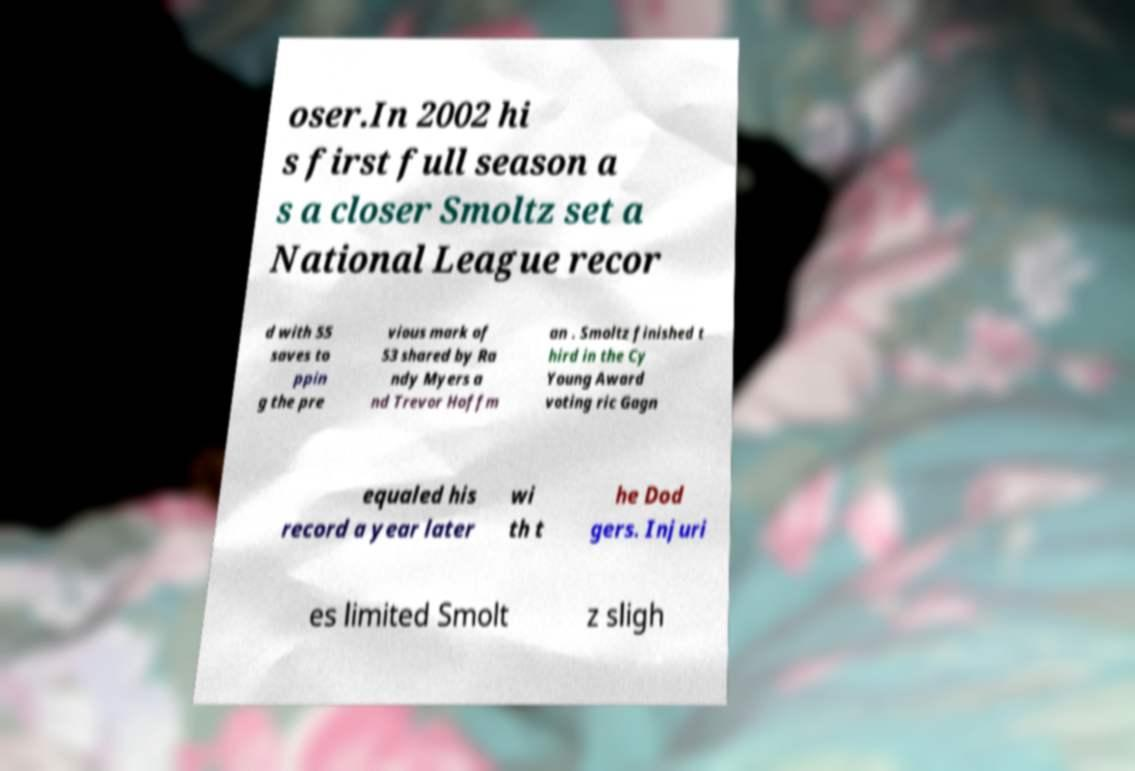Please read and relay the text visible in this image. What does it say? oser.In 2002 hi s first full season a s a closer Smoltz set a National League recor d with 55 saves to ppin g the pre vious mark of 53 shared by Ra ndy Myers a nd Trevor Hoffm an . Smoltz finished t hird in the Cy Young Award voting ric Gagn equaled his record a year later wi th t he Dod gers. Injuri es limited Smolt z sligh 